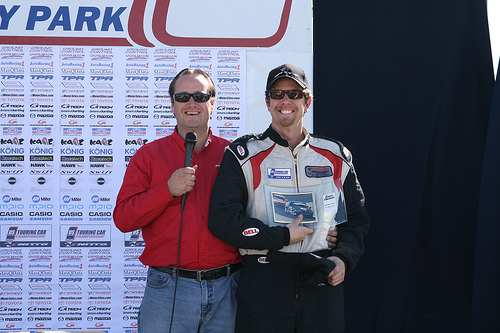<image>
Can you confirm if the man is behind the sign? No. The man is not behind the sign. From this viewpoint, the man appears to be positioned elsewhere in the scene. 